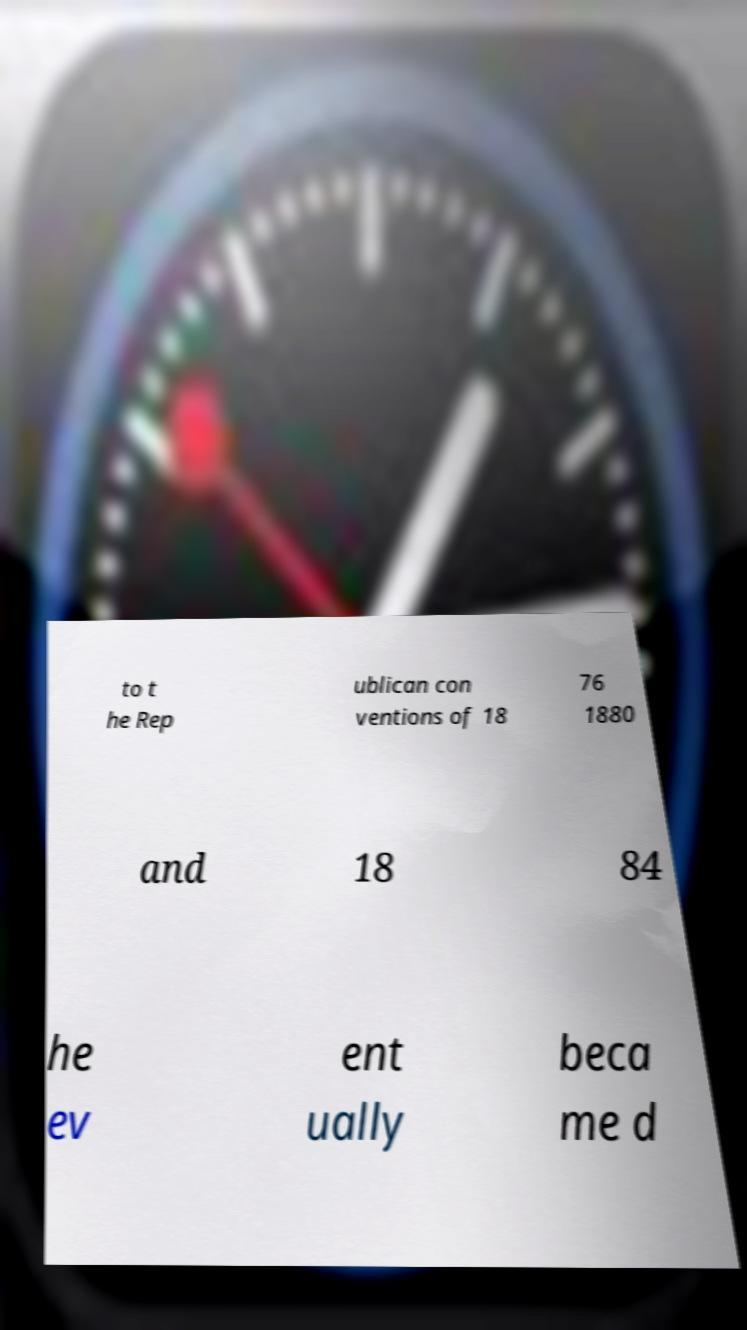For documentation purposes, I need the text within this image transcribed. Could you provide that? to t he Rep ublican con ventions of 18 76 1880 and 18 84 he ev ent ually beca me d 